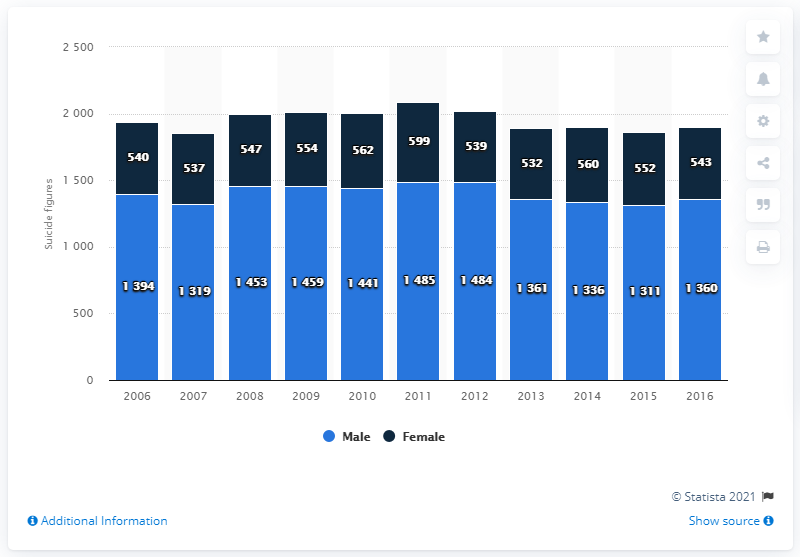Give some essential details in this illustration. In 2016, there were 543 female suicides in Belgium. 